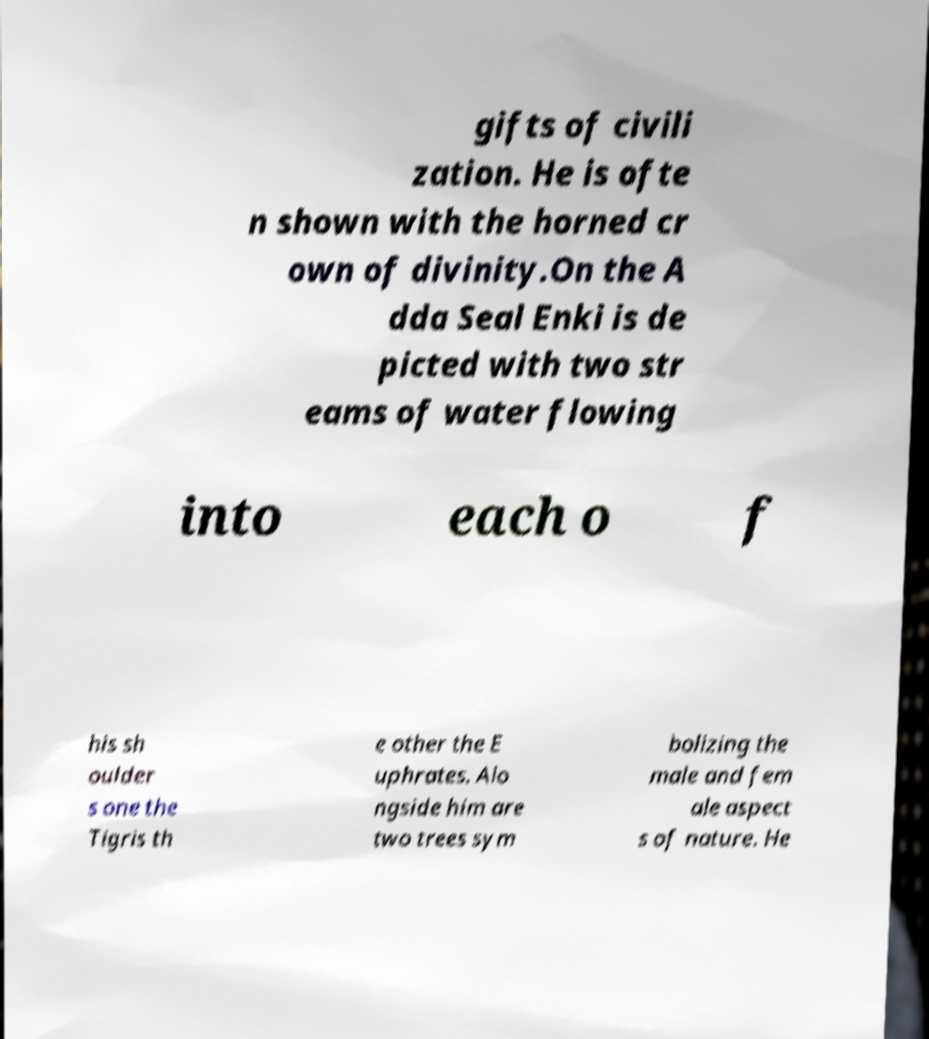There's text embedded in this image that I need extracted. Can you transcribe it verbatim? gifts of civili zation. He is ofte n shown with the horned cr own of divinity.On the A dda Seal Enki is de picted with two str eams of water flowing into each o f his sh oulder s one the Tigris th e other the E uphrates. Alo ngside him are two trees sym bolizing the male and fem ale aspect s of nature. He 